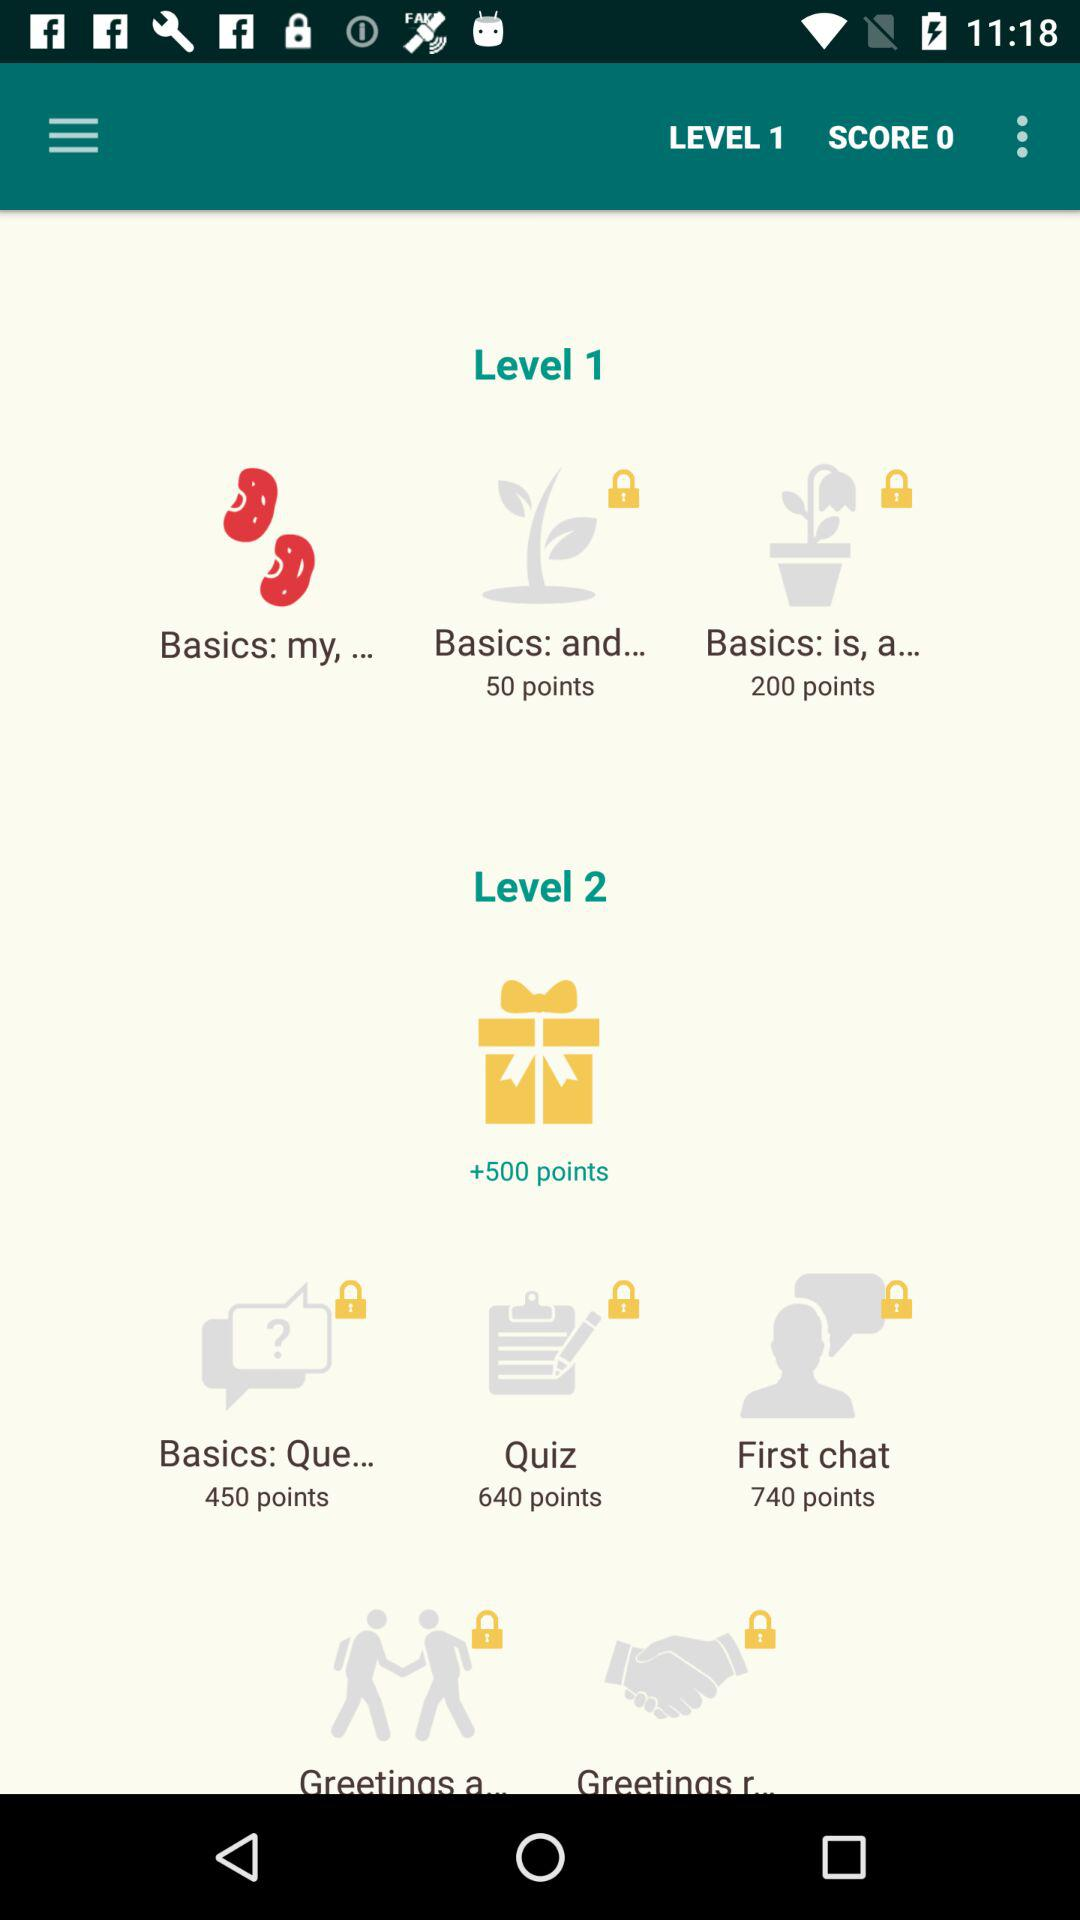What is the score? The score is 0. 